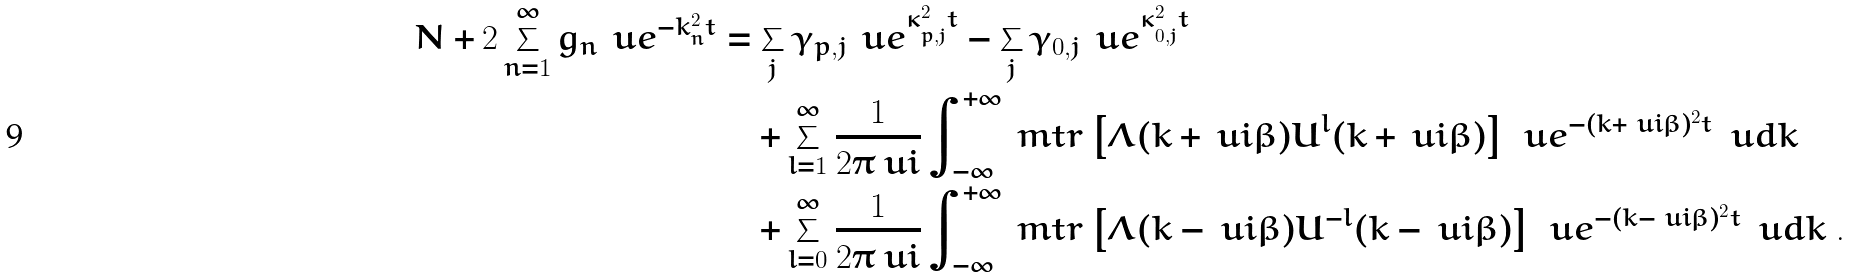Convert formula to latex. <formula><loc_0><loc_0><loc_500><loc_500>N + 2 \sum _ { n = 1 } ^ { \infty } g _ { n } \, \ u e ^ { - k _ { n } ^ { 2 } t } & = \sum _ { j } \gamma _ { p , j } \, \ u e ^ { \kappa _ { p , j } ^ { 2 } t } - \sum _ { j } \gamma _ { 0 , j } \, \ u e ^ { \kappa _ { 0 , j } ^ { 2 } t } \\ & \quad + \sum _ { l = 1 } ^ { \infty } \frac { 1 } { 2 \pi \ u i } \int _ { - \infty } ^ { + \infty } \ m t r \left [ \Lambda ( k + \ u i \beta ) U ^ { l } ( k + \ u i \beta ) \right ] \, \ u e ^ { - ( k + \ u i \beta ) ^ { 2 } t } \ \ u d k \\ & \quad + \sum _ { l = 0 } ^ { \infty } \frac { 1 } { 2 \pi \ u i } \int _ { - \infty } ^ { + \infty } \ m t r \left [ \Lambda ( k - \ u i \beta ) U ^ { - l } ( k - \ u i \beta ) \right ] \, \ u e ^ { - ( k - \ u i \beta ) ^ { 2 } t } \ \ u d k \ .</formula> 